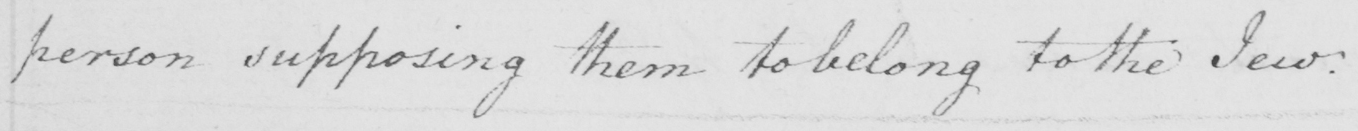Can you read and transcribe this handwriting? person supposing them to belong to the Jew . 